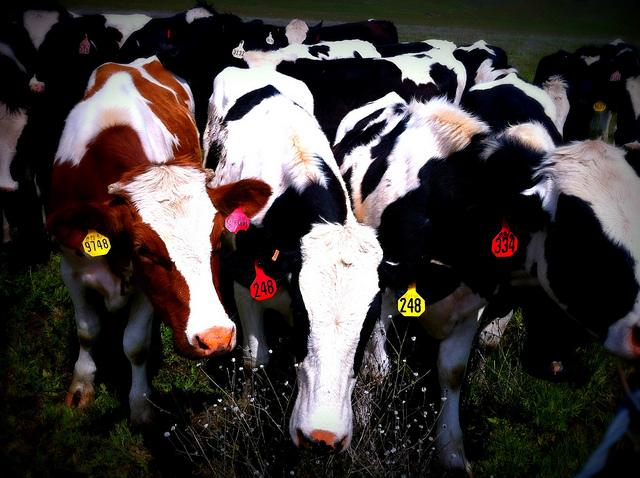What animals have the tags on them? Please explain your reasoning. cows. They're cows. 